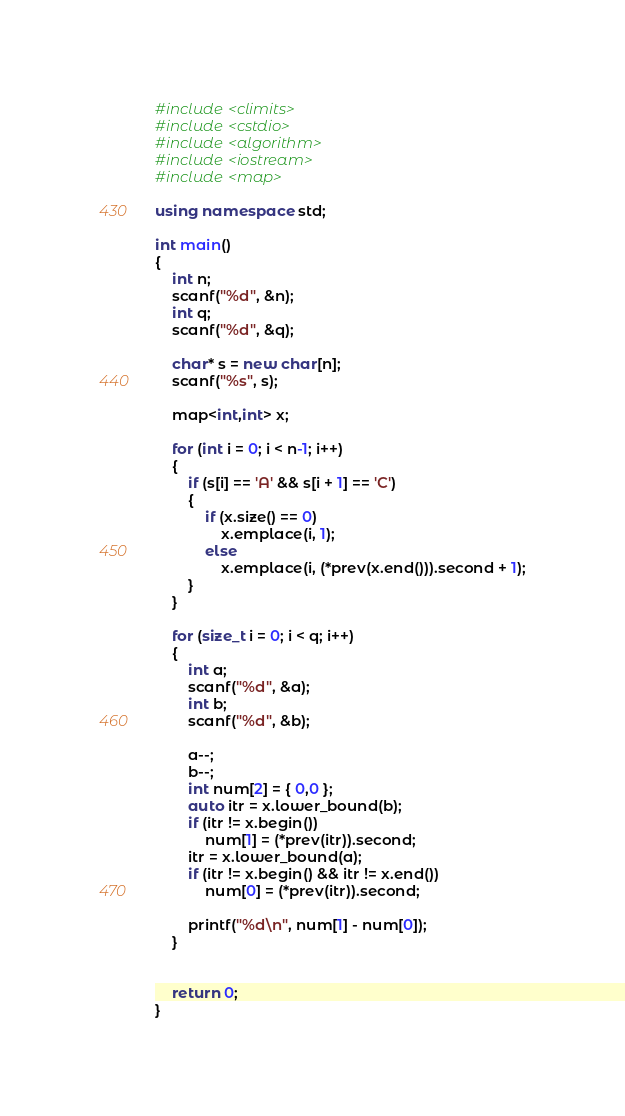Convert code to text. <code><loc_0><loc_0><loc_500><loc_500><_C++_>
#include <climits>
#include <cstdio>
#include <algorithm>
#include <iostream>
#include <map>

using namespace std;

int main()
{
	int n;
	scanf("%d", &n);
	int q;
	scanf("%d", &q);

	char* s = new char[n];
	scanf("%s", s);

	map<int,int> x;

	for (int i = 0; i < n-1; i++)
	{
		if (s[i] == 'A' && s[i + 1] == 'C')
		{
			if (x.size() == 0)
				x.emplace(i, 1);
			else
				x.emplace(i, (*prev(x.end())).second + 1);
		}
	}

	for (size_t i = 0; i < q; i++)
	{
		int a;
		scanf("%d", &a);
		int b;
		scanf("%d", &b);

		a--;
		b--;
		int num[2] = { 0,0 };
		auto itr = x.lower_bound(b);
		if (itr != x.begin())
			num[1] = (*prev(itr)).second;
		itr = x.lower_bound(a);
		if (itr != x.begin() && itr != x.end())
			num[0] = (*prev(itr)).second;

		printf("%d\n", num[1] - num[0]);
	}


	return 0;
}</code> 